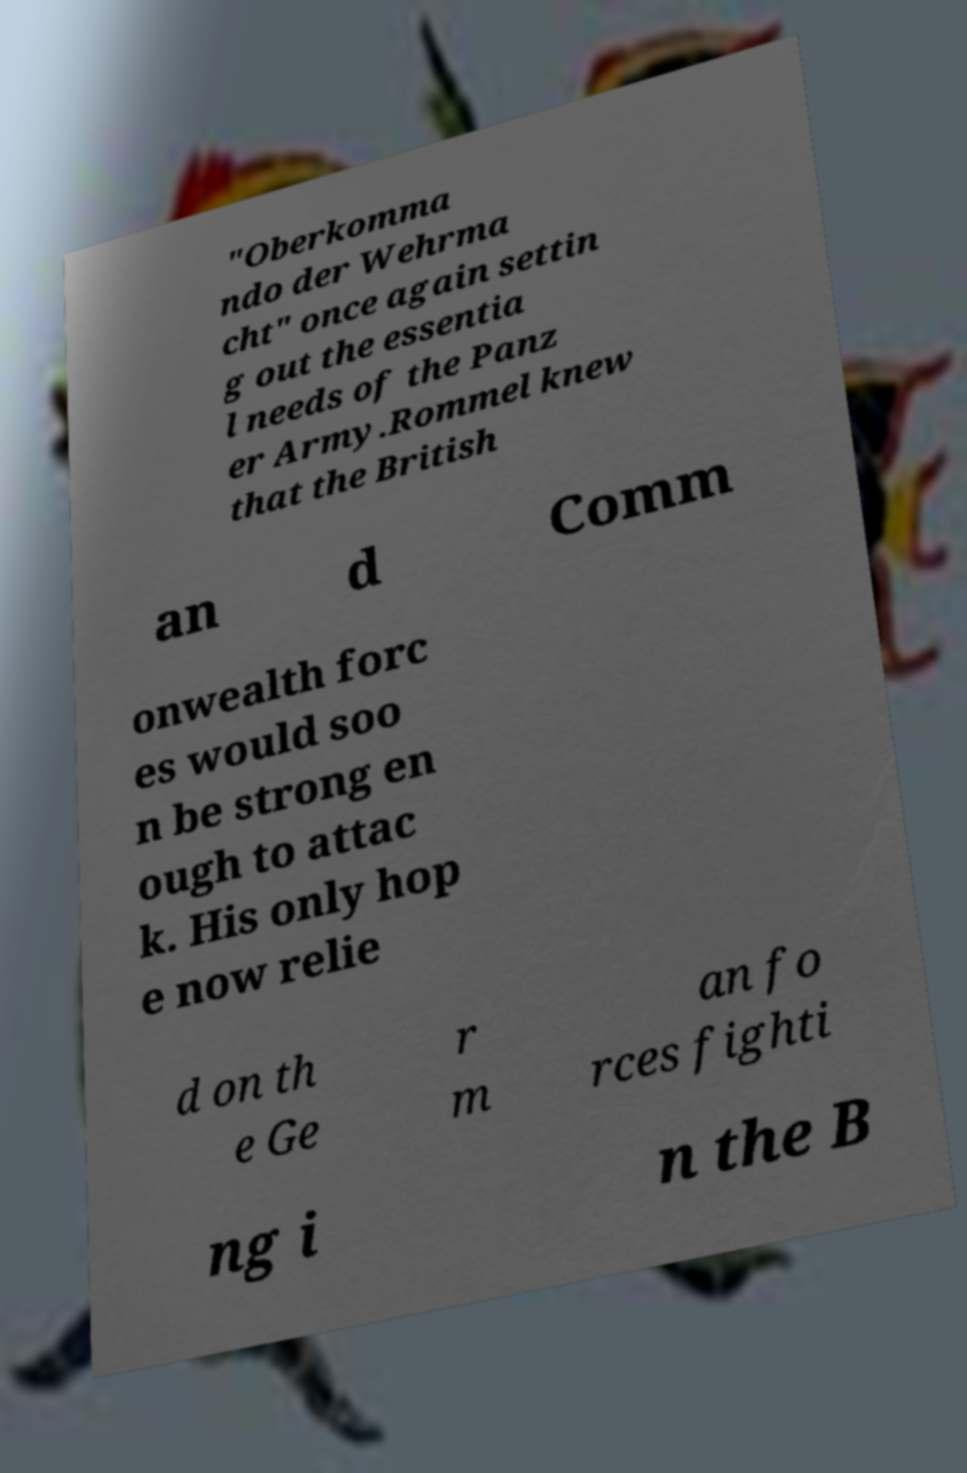There's text embedded in this image that I need extracted. Can you transcribe it verbatim? "Oberkomma ndo der Wehrma cht" once again settin g out the essentia l needs of the Panz er Army.Rommel knew that the British an d Comm onwealth forc es would soo n be strong en ough to attac k. His only hop e now relie d on th e Ge r m an fo rces fighti ng i n the B 